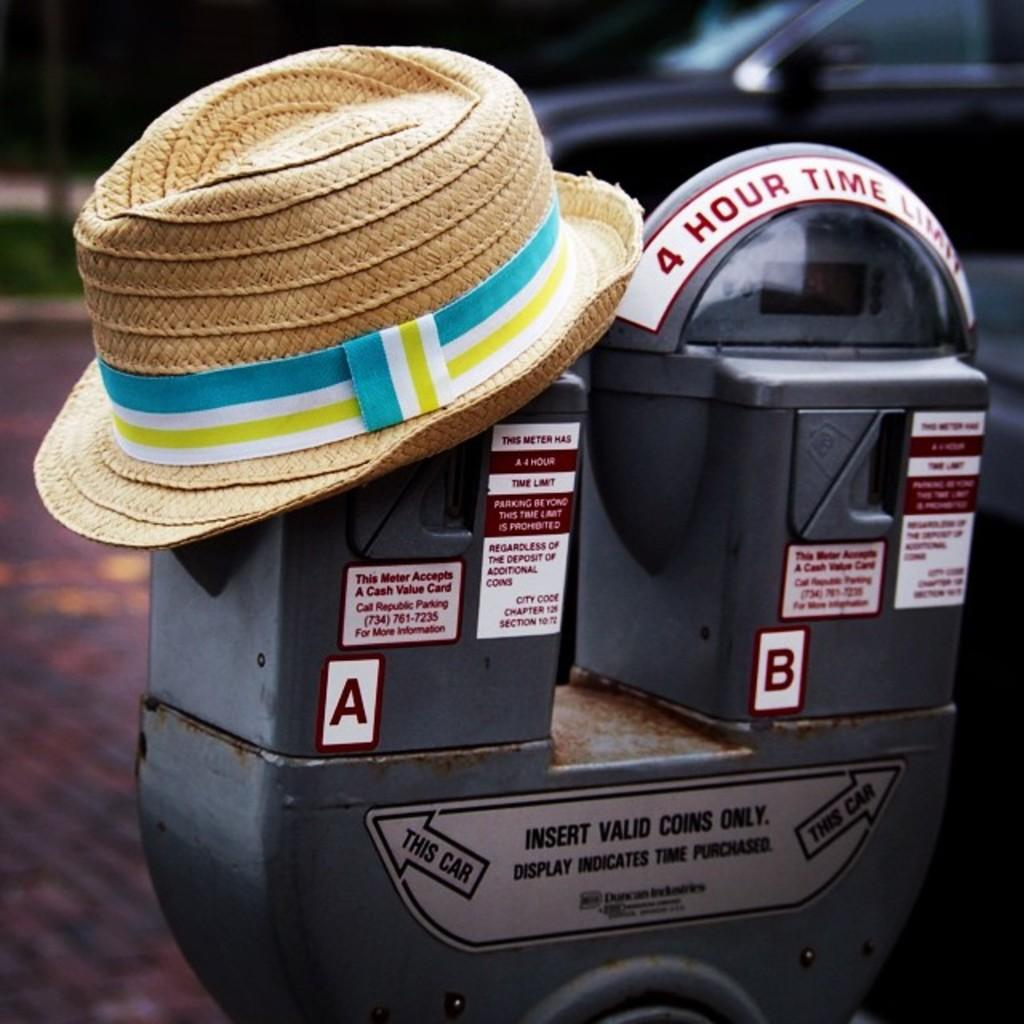<image>
Relay a brief, clear account of the picture shown. Straw hat on top of a toll meter that says the letter A. 